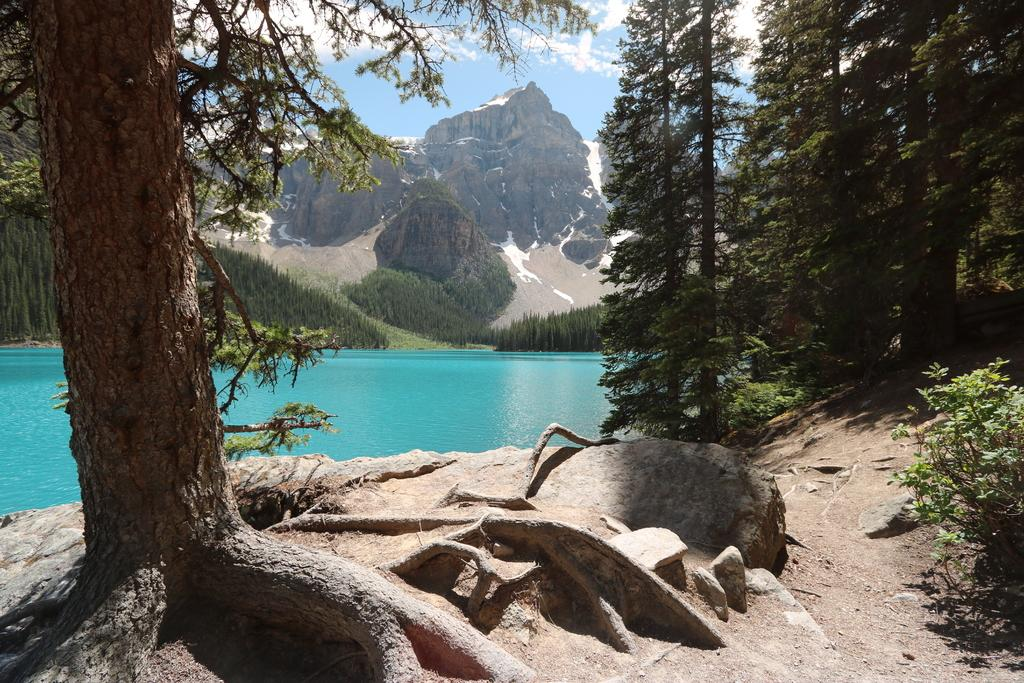What is the main feature in the center of the image? There is a sea in the center of the image. What can be seen in the distance behind the sea? There are mountains in the background of the image. What type of vegetation is visible in the background of the image? There are trees and other plants in the background of the image. What time is displayed on the clock in the image? There is no clock present in the image. How does the wave feel in the image? There is no wave present in the image, so it is not possible to determine how it might feel. 